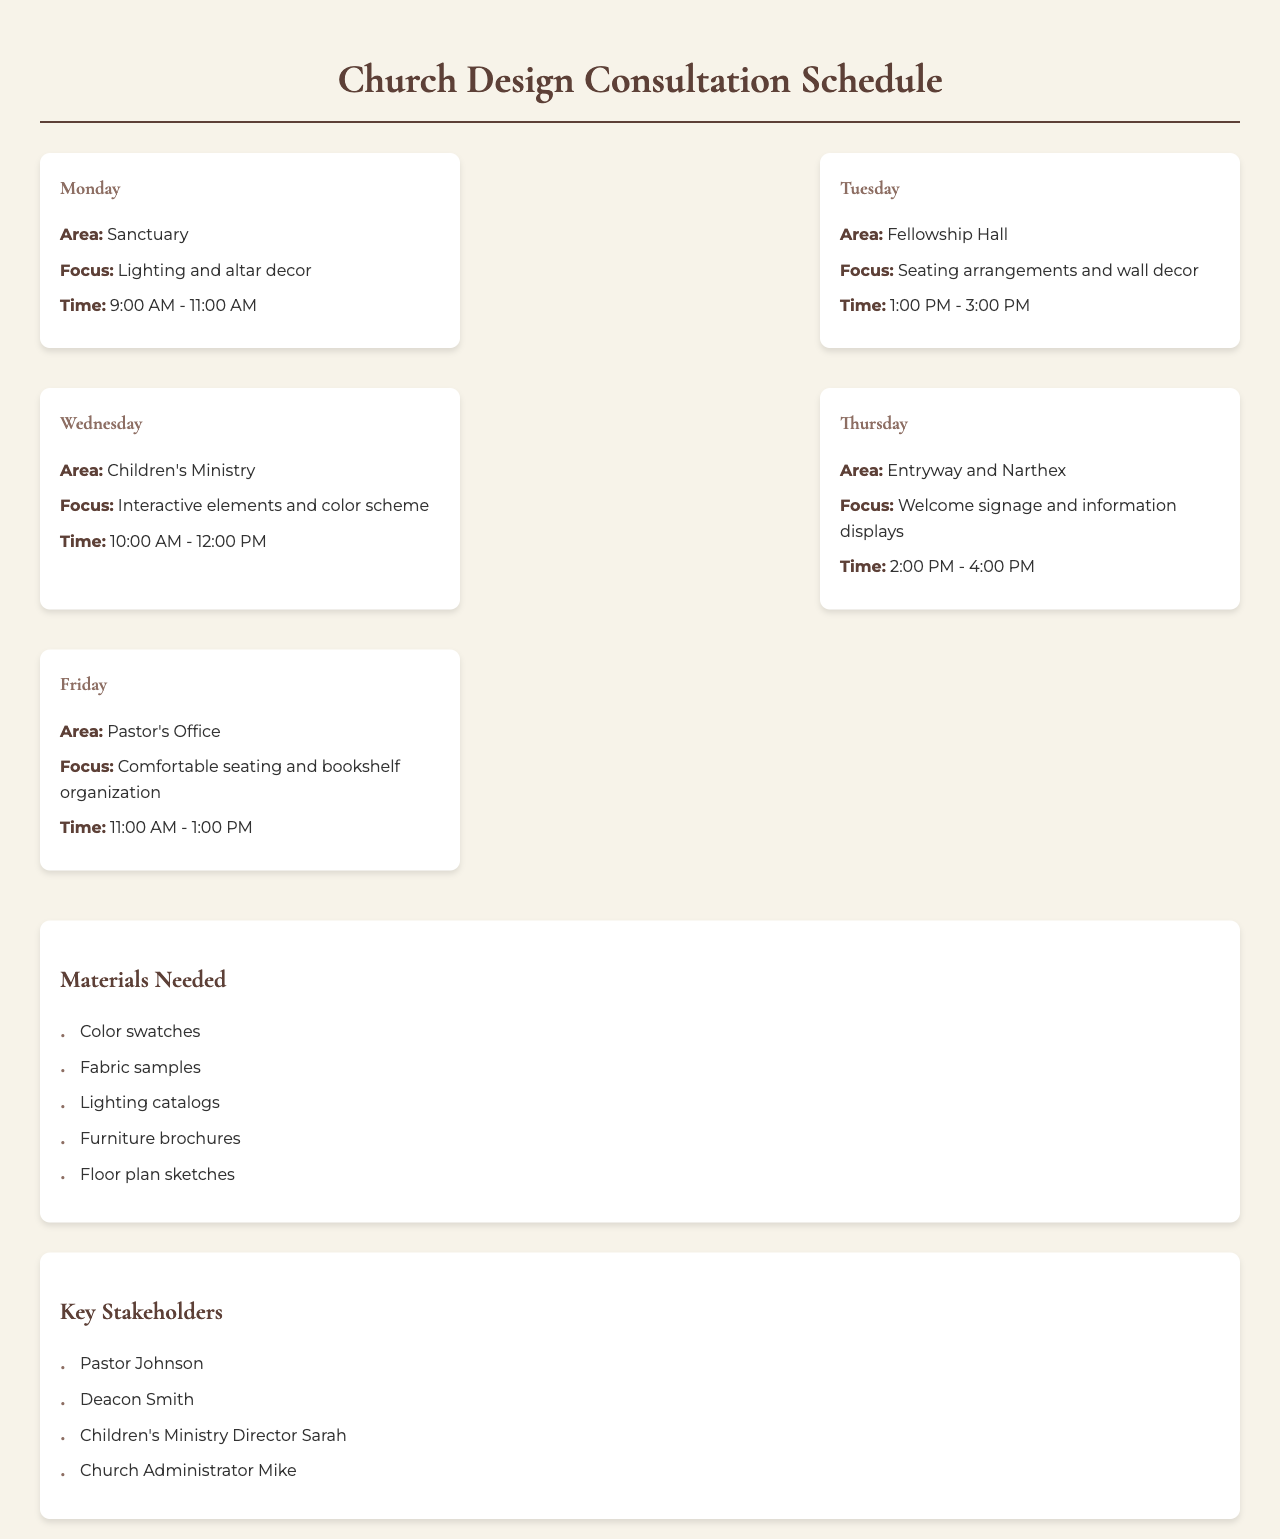What day is the consultation for the Children's Ministry? The day for the Children's Ministry consultation is listed in the schedule provided in the document.
Answer: Wednesday What time is the consultation for the Entryway and Narthex? The time for the Entryway and Narthex consultation can be found in the schedule section of the document.
Answer: 2:00 PM - 4:00 PM What materials are needed for the consultations? The materials needed are listed in a specific section of the document containing all necessary items for the design consultations.
Answer: Color swatches, Fabric samples, Lighting catalogs, Furniture brochures, Floor plan sketches Who is the Children's Ministry Director mentioned in the document? The name of the Children's Ministry Director is stated in the key stakeholders' section of the document.
Answer: Sarah How many areas have consultations scheduled for Monday? The document outlines the schedule and specifies consultations by day, helping to determine the number of areas scheduled for that day.
Answer: 1 What is the focus of the consultation on Friday? The focus for the Friday consultation is defined in the schedule in relation to the Pastor's Office consultation.
Answer: Comfortable seating and bookshelf organization Which area has consultations scheduled for Tuesday? The schedule specifies the area designated for consultation on Tuesday and highlights it in the document.
Answer: Fellowship Hall What is the total number of key stakeholders listed in the document? The number of key stakeholders is explicitly stated in the section dedicated to those involved in the consultations.
Answer: 4 What is the focus of the consultation for the Sanctuary? The focus for the Sanctuary consultation can be found in the daily consultations outlined in the document.
Answer: Lighting and altar decor 